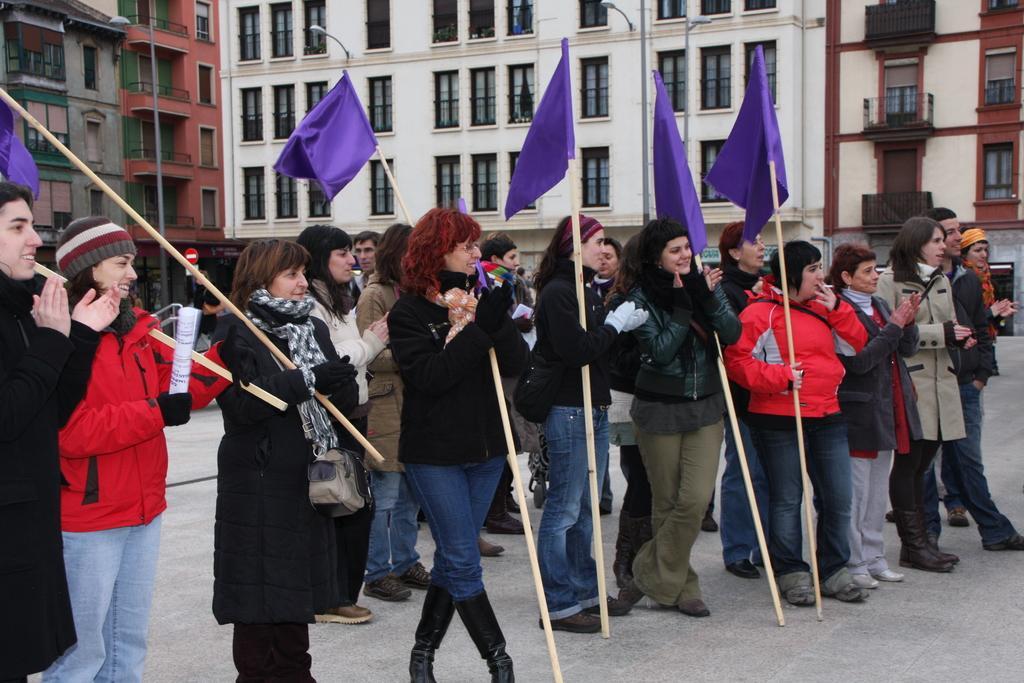Describe this image in one or two sentences. In this picture I can see a number of people holding the flags. I can see the buildings in the background. 